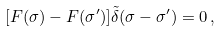Convert formula to latex. <formula><loc_0><loc_0><loc_500><loc_500>[ F ( \sigma ) - F ( \sigma ^ { \prime } ) ] \tilde { \delta } ( \sigma - \sigma ^ { \prime } ) = 0 \, ,</formula> 